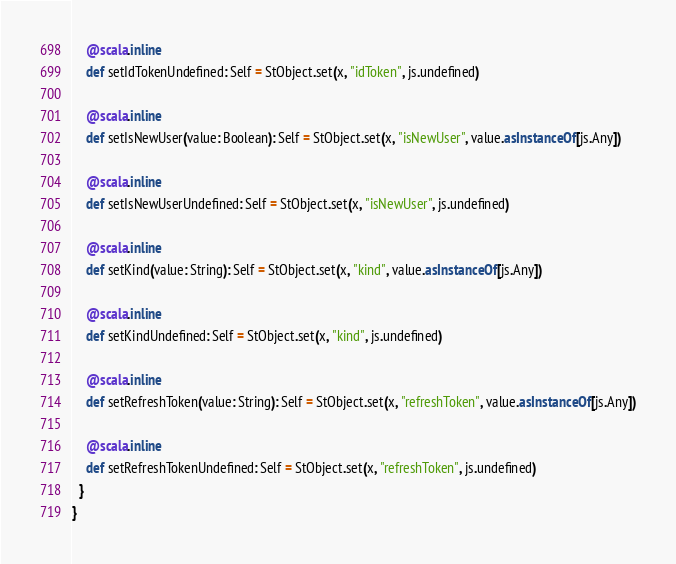Convert code to text. <code><loc_0><loc_0><loc_500><loc_500><_Scala_>    @scala.inline
    def setIdTokenUndefined: Self = StObject.set(x, "idToken", js.undefined)
    
    @scala.inline
    def setIsNewUser(value: Boolean): Self = StObject.set(x, "isNewUser", value.asInstanceOf[js.Any])
    
    @scala.inline
    def setIsNewUserUndefined: Self = StObject.set(x, "isNewUser", js.undefined)
    
    @scala.inline
    def setKind(value: String): Self = StObject.set(x, "kind", value.asInstanceOf[js.Any])
    
    @scala.inline
    def setKindUndefined: Self = StObject.set(x, "kind", js.undefined)
    
    @scala.inline
    def setRefreshToken(value: String): Self = StObject.set(x, "refreshToken", value.asInstanceOf[js.Any])
    
    @scala.inline
    def setRefreshTokenUndefined: Self = StObject.set(x, "refreshToken", js.undefined)
  }
}
</code> 